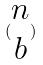<formula> <loc_0><loc_0><loc_500><loc_500>( \begin{matrix} n \\ b \end{matrix} )</formula> 